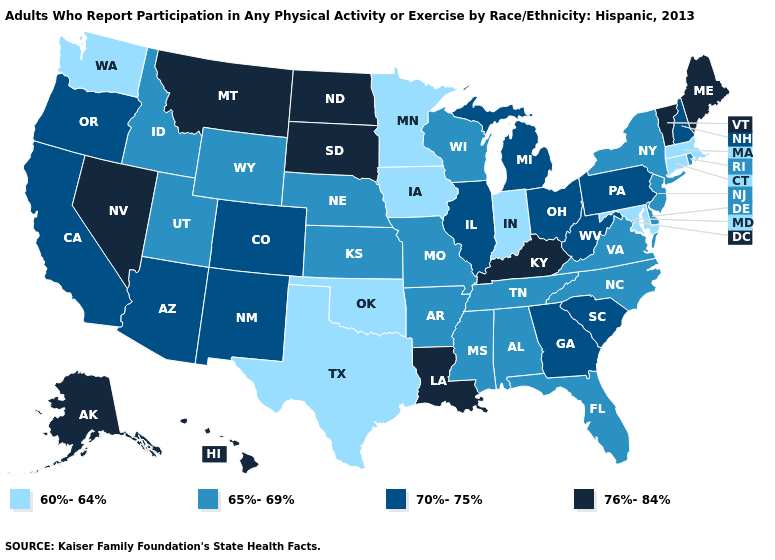Which states have the highest value in the USA?
Give a very brief answer. Alaska, Hawaii, Kentucky, Louisiana, Maine, Montana, Nevada, North Dakota, South Dakota, Vermont. Does North Dakota have the same value as Kentucky?
Give a very brief answer. Yes. Which states have the lowest value in the South?
Keep it brief. Maryland, Oklahoma, Texas. Which states have the lowest value in the South?
Give a very brief answer. Maryland, Oklahoma, Texas. What is the lowest value in the USA?
Keep it brief. 60%-64%. Among the states that border Missouri , which have the highest value?
Answer briefly. Kentucky. Does Indiana have a lower value than Arizona?
Be succinct. Yes. Name the states that have a value in the range 60%-64%?
Answer briefly. Connecticut, Indiana, Iowa, Maryland, Massachusetts, Minnesota, Oklahoma, Texas, Washington. What is the value of Virginia?
Quick response, please. 65%-69%. Name the states that have a value in the range 60%-64%?
Quick response, please. Connecticut, Indiana, Iowa, Maryland, Massachusetts, Minnesota, Oklahoma, Texas, Washington. Does North Dakota have the lowest value in the USA?
Answer briefly. No. Does the first symbol in the legend represent the smallest category?
Quick response, please. Yes. Name the states that have a value in the range 70%-75%?
Short answer required. Arizona, California, Colorado, Georgia, Illinois, Michigan, New Hampshire, New Mexico, Ohio, Oregon, Pennsylvania, South Carolina, West Virginia. Among the states that border Washington , which have the lowest value?
Concise answer only. Idaho. Name the states that have a value in the range 65%-69%?
Short answer required. Alabama, Arkansas, Delaware, Florida, Idaho, Kansas, Mississippi, Missouri, Nebraska, New Jersey, New York, North Carolina, Rhode Island, Tennessee, Utah, Virginia, Wisconsin, Wyoming. 